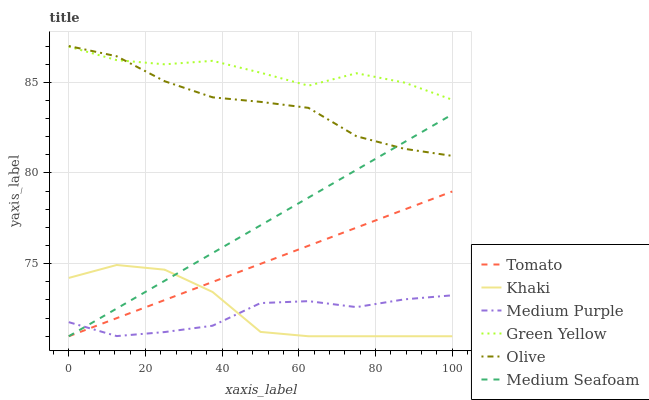Does Medium Purple have the minimum area under the curve?
Answer yes or no. Yes. Does Green Yellow have the maximum area under the curve?
Answer yes or no. Yes. Does Khaki have the minimum area under the curve?
Answer yes or no. No. Does Khaki have the maximum area under the curve?
Answer yes or no. No. Is Tomato the smoothest?
Answer yes or no. Yes. Is Khaki the roughest?
Answer yes or no. Yes. Is Medium Purple the smoothest?
Answer yes or no. No. Is Medium Purple the roughest?
Answer yes or no. No. Does Tomato have the lowest value?
Answer yes or no. Yes. Does Medium Purple have the lowest value?
Answer yes or no. No. Does Olive have the highest value?
Answer yes or no. Yes. Does Khaki have the highest value?
Answer yes or no. No. Is Medium Purple less than Green Yellow?
Answer yes or no. Yes. Is Green Yellow greater than Tomato?
Answer yes or no. Yes. Does Tomato intersect Medium Seafoam?
Answer yes or no. Yes. Is Tomato less than Medium Seafoam?
Answer yes or no. No. Is Tomato greater than Medium Seafoam?
Answer yes or no. No. Does Medium Purple intersect Green Yellow?
Answer yes or no. No. 